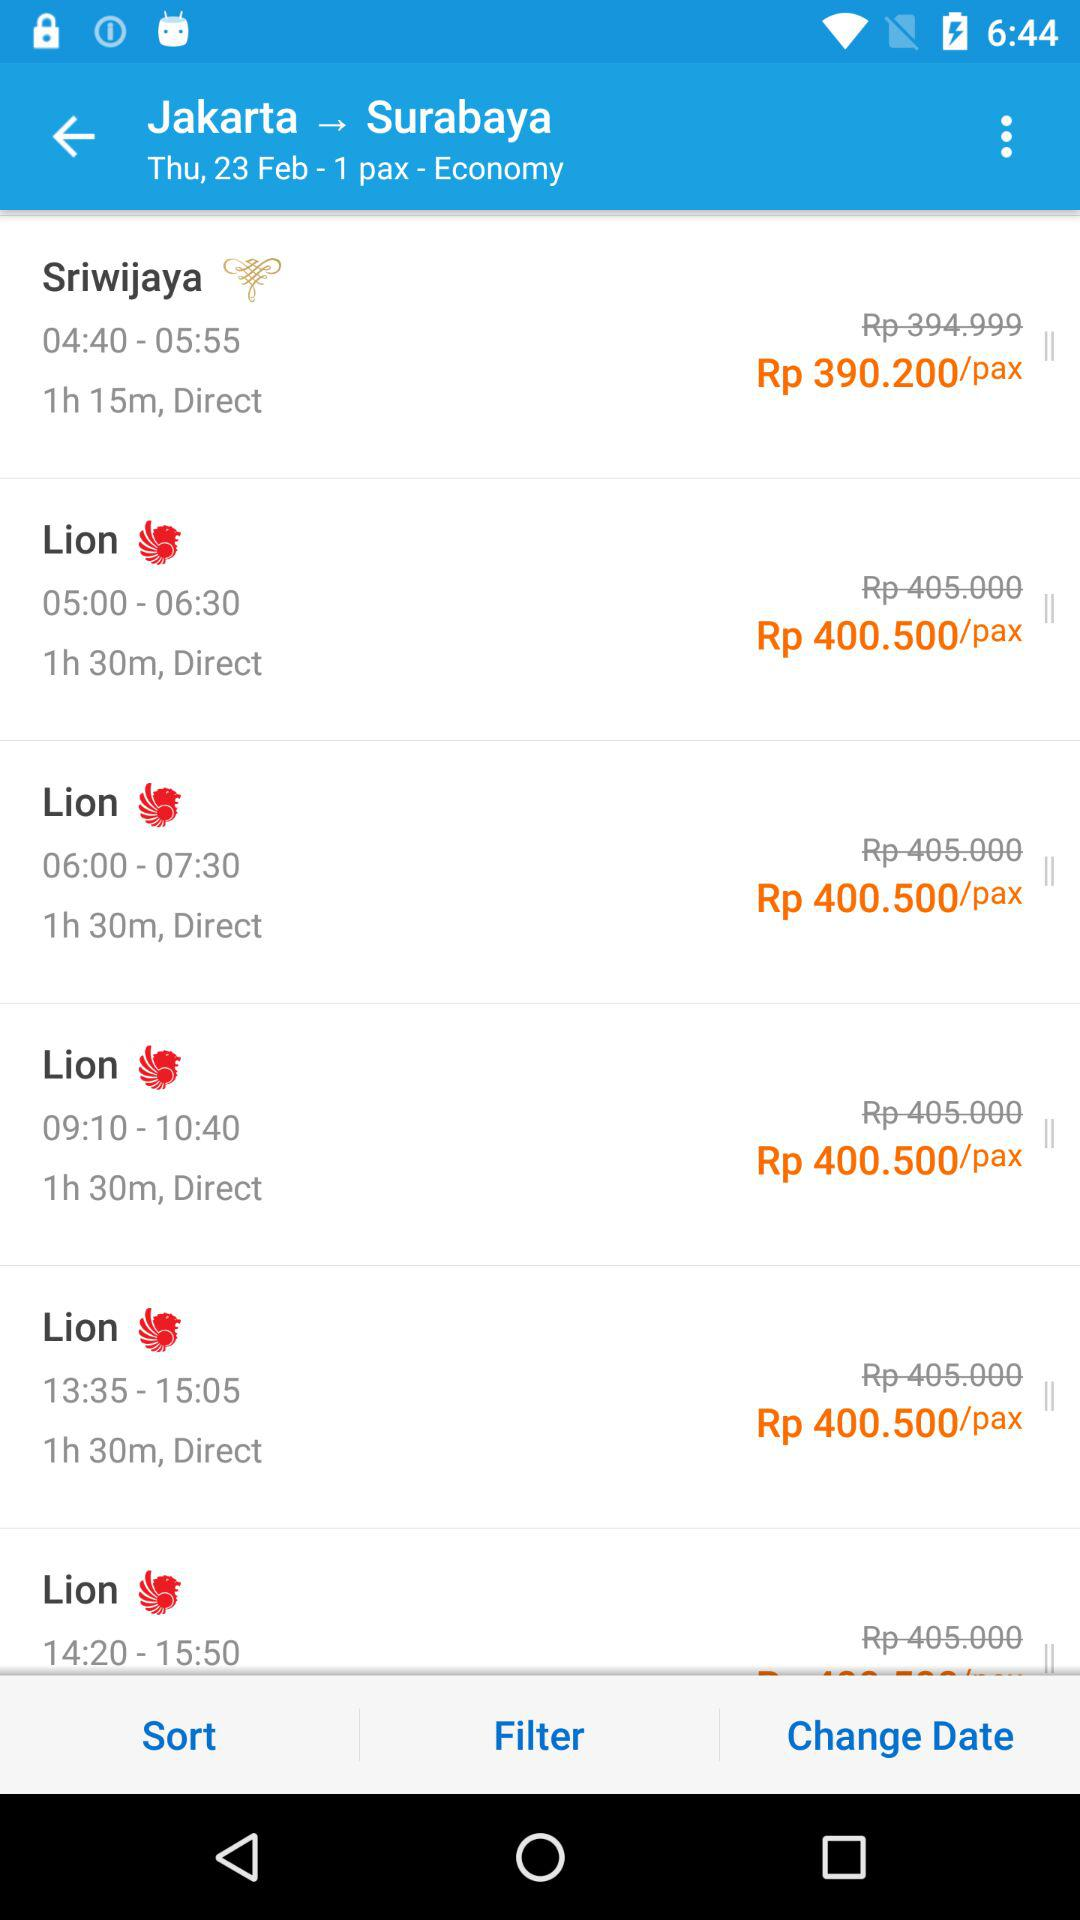What is the discounted ticket price for traveling by "Sriwijaya"? The discounted ticket price for traveling by "Sriwijaya" is Rp 390.200 per passenger. 